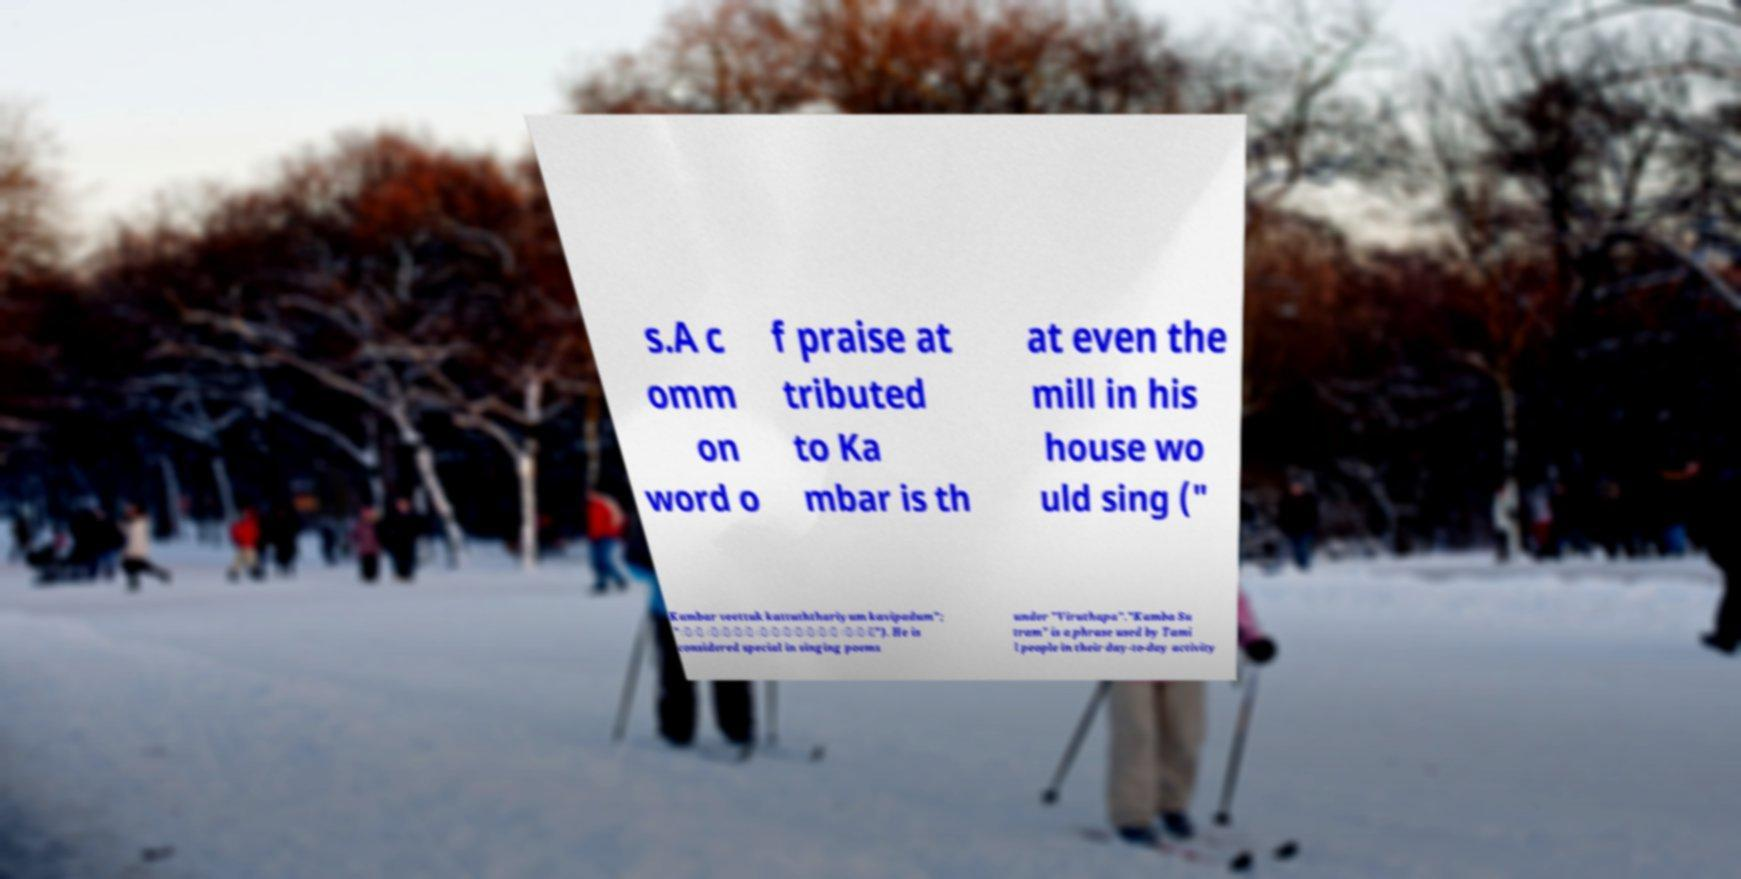There's text embedded in this image that I need extracted. Can you transcribe it verbatim? s.A c omm on word o f praise at tributed to Ka mbar is th at even the mill in his house wo uld sing (" Kambar veettuk kattuththariyum kavipadum"; "்் ீ்ு் ்ு்ிு்ி ாு்"). He is considered special in singing poems under "Viruthapa"."Kamba Su tram" is a phrase used by Tami l people in their day-to-day activity 